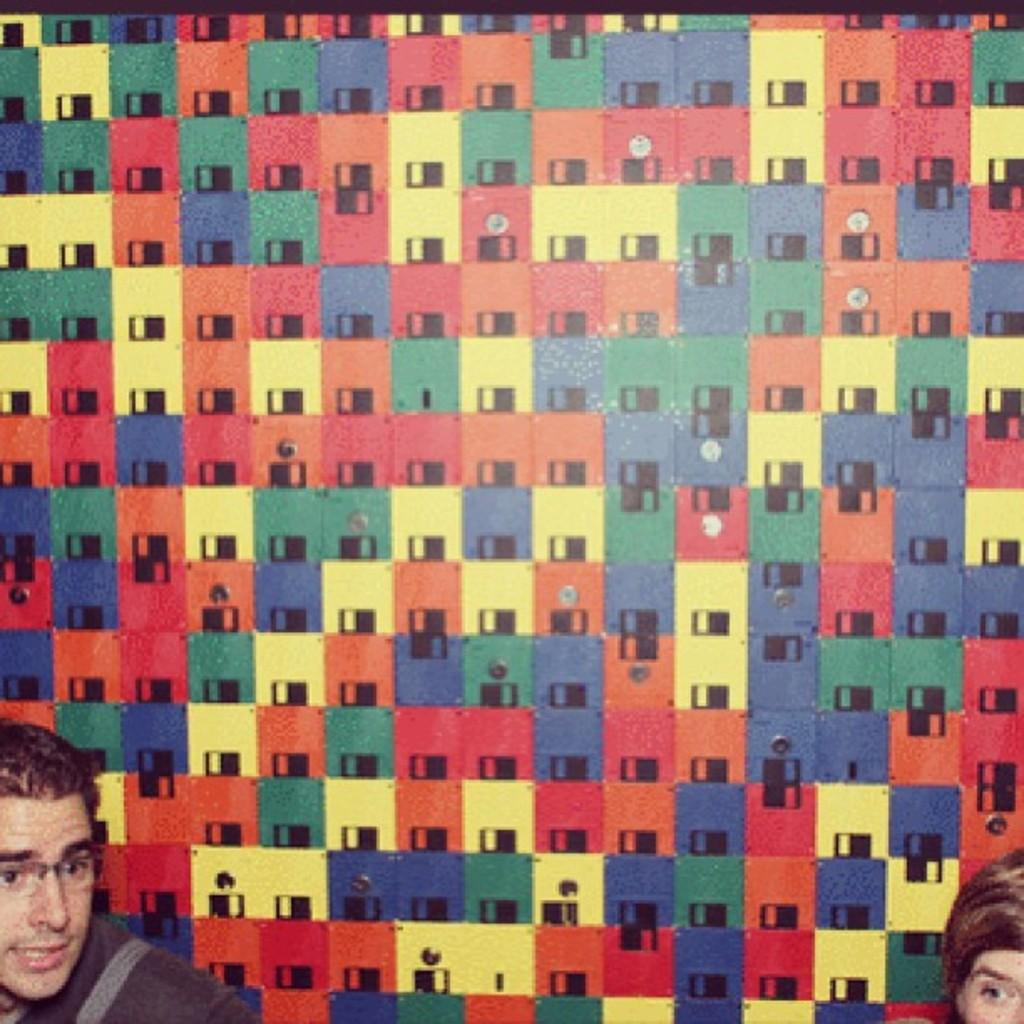Who is present in the bottom left corner of the image? There is a man in the bottom left corner of the image. Who is present in the bottom right corner of the image? There is another person in the bottom right corner of the image. What can be seen in the background of the image? There is a wall in the background of the image. What type of bread is the daughter holding in the image? There is no daughter or bread present in the image. Is the doll in the image playing with the man in the bottom left corner? There is no doll present in the image. 